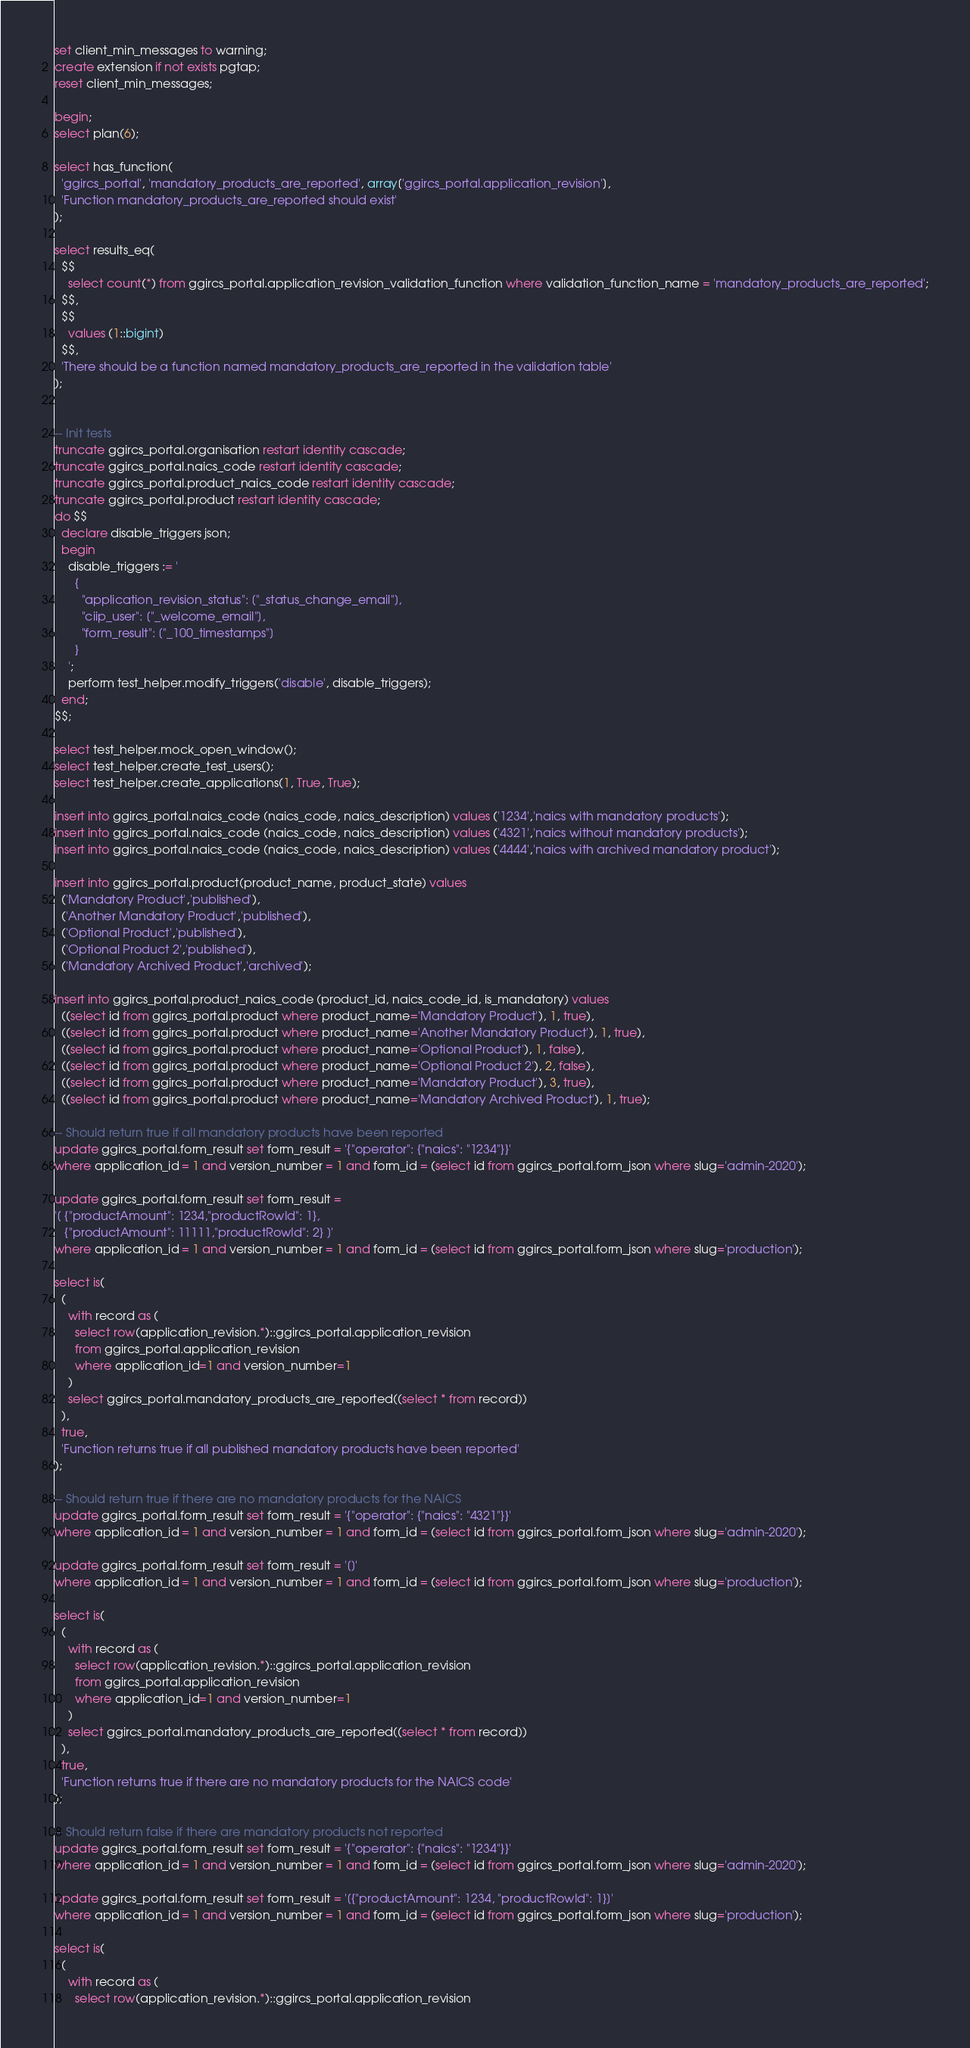<code> <loc_0><loc_0><loc_500><loc_500><_SQL_>set client_min_messages to warning;
create extension if not exists pgtap;
reset client_min_messages;

begin;
select plan(6);

select has_function(
  'ggircs_portal', 'mandatory_products_are_reported', array['ggircs_portal.application_revision'],
  'Function mandatory_products_are_reported should exist'
);

select results_eq(
  $$
    select count(*) from ggircs_portal.application_revision_validation_function where validation_function_name = 'mandatory_products_are_reported';
  $$,
  $$
    values (1::bigint)
  $$,
  'There should be a function named mandatory_products_are_reported in the validation table'
);


-- Init tests
truncate ggircs_portal.organisation restart identity cascade;
truncate ggircs_portal.naics_code restart identity cascade;
truncate ggircs_portal.product_naics_code restart identity cascade;
truncate ggircs_portal.product restart identity cascade;
do $$
  declare disable_triggers json;
  begin
    disable_triggers := '
      {
        "application_revision_status": ["_status_change_email"],
        "ciip_user": ["_welcome_email"],
        "form_result": ["_100_timestamps"]
      }
    ';
    perform test_helper.modify_triggers('disable', disable_triggers);
  end;
$$;

select test_helper.mock_open_window();
select test_helper.create_test_users();
select test_helper.create_applications(1, True, True);

insert into ggircs_portal.naics_code (naics_code, naics_description) values ('1234','naics with mandatory products');
insert into ggircs_portal.naics_code (naics_code, naics_description) values ('4321','naics without mandatory products');
insert into ggircs_portal.naics_code (naics_code, naics_description) values ('4444','naics with archived mandatory product');

insert into ggircs_portal.product(product_name, product_state) values
  ('Mandatory Product','published'),
  ('Another Mandatory Product','published'),
  ('Optional Product','published'),
  ('Optional Product 2','published'),
  ('Mandatory Archived Product','archived');

insert into ggircs_portal.product_naics_code (product_id, naics_code_id, is_mandatory) values
  ((select id from ggircs_portal.product where product_name='Mandatory Product'), 1, true),
  ((select id from ggircs_portal.product where product_name='Another Mandatory Product'), 1, true),
  ((select id from ggircs_portal.product where product_name='Optional Product'), 1, false),
  ((select id from ggircs_portal.product where product_name='Optional Product 2'), 2, false),
  ((select id from ggircs_portal.product where product_name='Mandatory Product'), 3, true),
  ((select id from ggircs_portal.product where product_name='Mandatory Archived Product'), 1, true);

-- Should return true if all mandatory products have been reported
update ggircs_portal.form_result set form_result = '{"operator": {"naics": "1234"}}'
where application_id = 1 and version_number = 1 and form_id = (select id from ggircs_portal.form_json where slug='admin-2020');

update ggircs_portal.form_result set form_result =
'[ {"productAmount": 1234,"productRowId": 1},
   {"productAmount": 11111,"productRowId": 2} ]'
where application_id = 1 and version_number = 1 and form_id = (select id from ggircs_portal.form_json where slug='production');

select is(
  (
    with record as (
      select row(application_revision.*)::ggircs_portal.application_revision
      from ggircs_portal.application_revision
      where application_id=1 and version_number=1
    )
    select ggircs_portal.mandatory_products_are_reported((select * from record))
  ),
  true,
  'Function returns true if all published mandatory products have been reported'
);

-- Should return true if there are no mandatory products for the NAICS
update ggircs_portal.form_result set form_result = '{"operator": {"naics": "4321"}}'
where application_id = 1 and version_number = 1 and form_id = (select id from ggircs_portal.form_json where slug='admin-2020');

update ggircs_portal.form_result set form_result = '[]'
where application_id = 1 and version_number = 1 and form_id = (select id from ggircs_portal.form_json where slug='production');

select is(
  (
    with record as (
      select row(application_revision.*)::ggircs_portal.application_revision
      from ggircs_portal.application_revision
      where application_id=1 and version_number=1
    )
    select ggircs_portal.mandatory_products_are_reported((select * from record))
  ),
  true,
  'Function returns true if there are no mandatory products for the NAICS code'
);

-- Should return false if there are mandatory products not reported
update ggircs_portal.form_result set form_result = '{"operator": {"naics": "1234"}}'
where application_id = 1 and version_number = 1 and form_id = (select id from ggircs_portal.form_json where slug='admin-2020');

update ggircs_portal.form_result set form_result = '[{"productAmount": 1234, "productRowId": 1}]'
where application_id = 1 and version_number = 1 and form_id = (select id from ggircs_portal.form_json where slug='production');

select is(
  (
    with record as (
      select row(application_revision.*)::ggircs_portal.application_revision</code> 